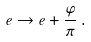<formula> <loc_0><loc_0><loc_500><loc_500>e \to e + \frac { \varphi } { \pi } \, .</formula> 